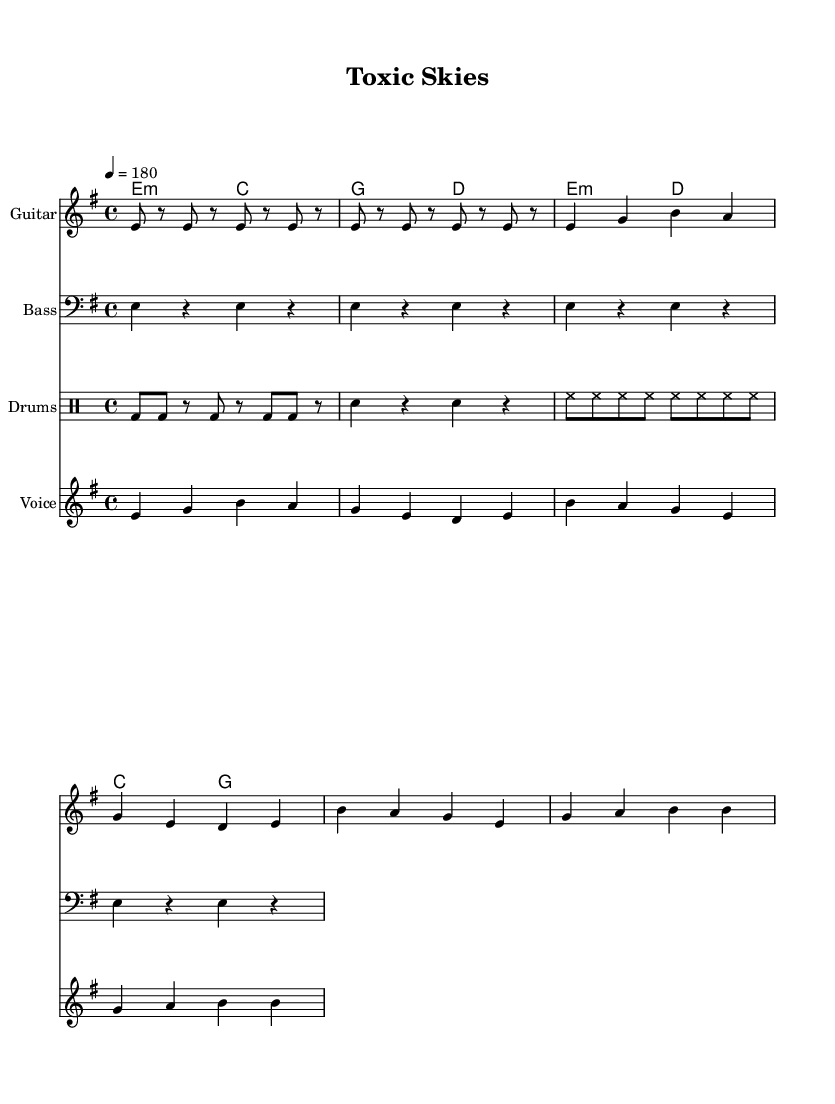What is the key signature of this music? The key signature is E minor, which has one sharp (F#). This can be determined from the key signature notation at the beginning of the score.
Answer: E minor What is the time signature of this piece? The time signature is 4/4, which indicates there are four beats in each measure and the quarter note gets one beat. This information can be found in the time signature notation in the score.
Answer: 4/4 What is the tempo marking of the piece? The tempo marking is 180, indicated by "4 = 180", meaning there are 180 quarter note beats per minute. This can be found in the tempo indication section of the score.
Answer: 180 How many measures are there in the verse? There are four measures in the verse, which can be counted from the segments of music notation in the verse section of the score.
Answer: 4 What chords are played in the chorus? The chords played in the chorus are E minor, D, C, and G. This can be determined from the chord mode notations in the score during the chorus section.
Answer: E minor, D, C, G How does the structure of this song reflect punk themes? The structure of the song with its fast tempo, straightforward chords, and aggressive lyrics reflect punk themes of rebellion and urgency, typically associated with punk music. This can be concluded from the overall composition and messaging within the sheet music.
Answer: Rebellion and urgency What is the main environmental issue addressed in the lyrics? The main environmental issue addressed in the lyrics is air pollution, specifically caused by military activities. This is apparent from key phrases in the lyrics that mention "polluting our air" and "toxic skies."
Answer: Air pollution 